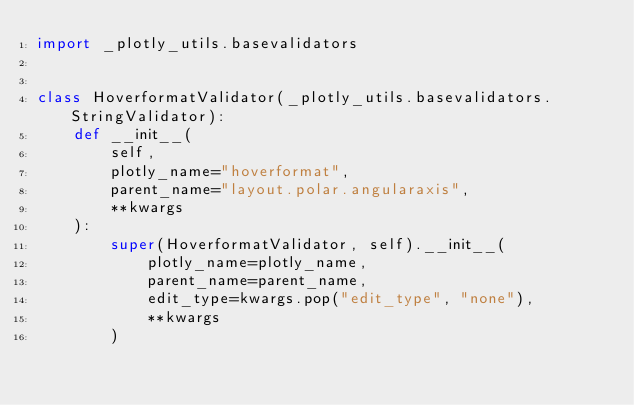Convert code to text. <code><loc_0><loc_0><loc_500><loc_500><_Python_>import _plotly_utils.basevalidators


class HoverformatValidator(_plotly_utils.basevalidators.StringValidator):
    def __init__(
        self,
        plotly_name="hoverformat",
        parent_name="layout.polar.angularaxis",
        **kwargs
    ):
        super(HoverformatValidator, self).__init__(
            plotly_name=plotly_name,
            parent_name=parent_name,
            edit_type=kwargs.pop("edit_type", "none"),
            **kwargs
        )
</code> 